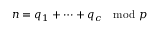Convert formula to latex. <formula><loc_0><loc_0><loc_500><loc_500>n = q _ { 1 } + \cdots + q _ { c } \mod p</formula> 